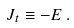Convert formula to latex. <formula><loc_0><loc_0><loc_500><loc_500>J _ { t } \equiv - E \, .</formula> 